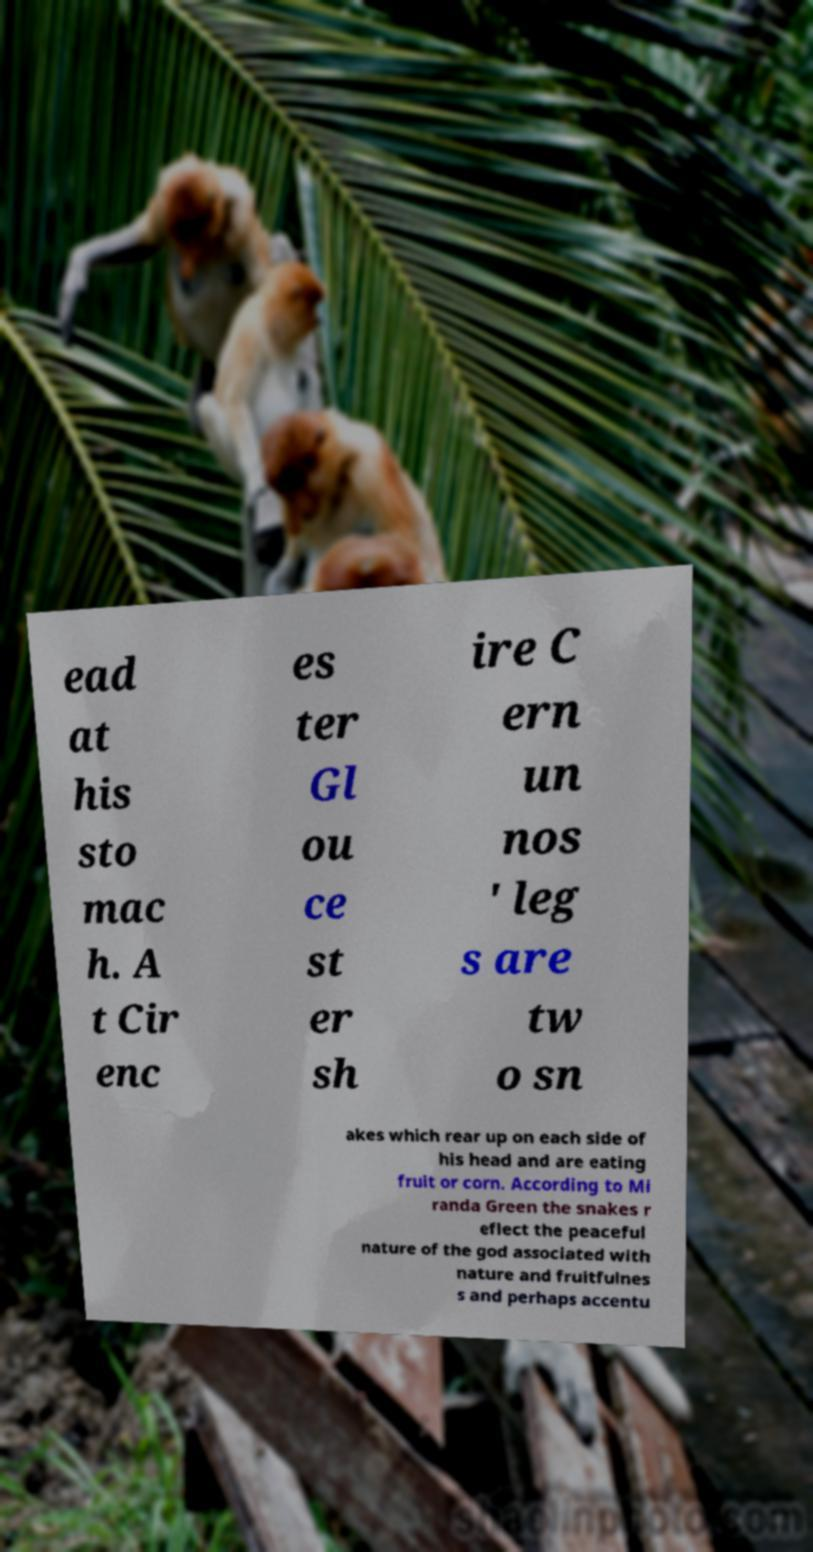I need the written content from this picture converted into text. Can you do that? ead at his sto mac h. A t Cir enc es ter Gl ou ce st er sh ire C ern un nos ' leg s are tw o sn akes which rear up on each side of his head and are eating fruit or corn. According to Mi randa Green the snakes r eflect the peaceful nature of the god associated with nature and fruitfulnes s and perhaps accentu 